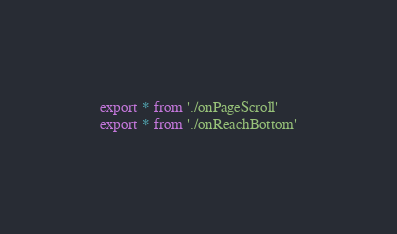Convert code to text. <code><loc_0><loc_0><loc_500><loc_500><_JavaScript_>export * from './onPageScroll'
export * from './onReachBottom'
</code> 